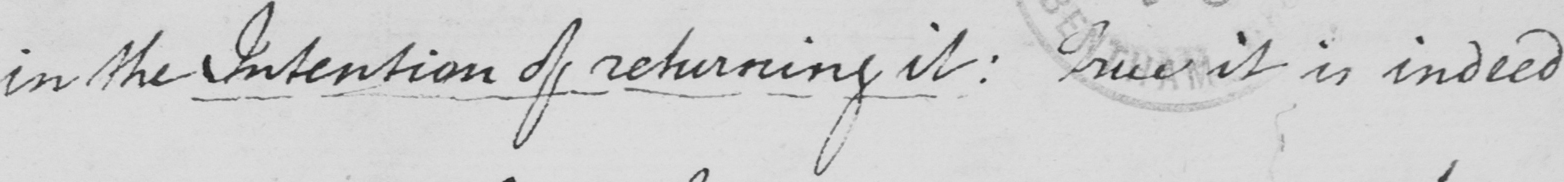What is written in this line of handwriting? in the Intention of returning it :  True it is indeed 